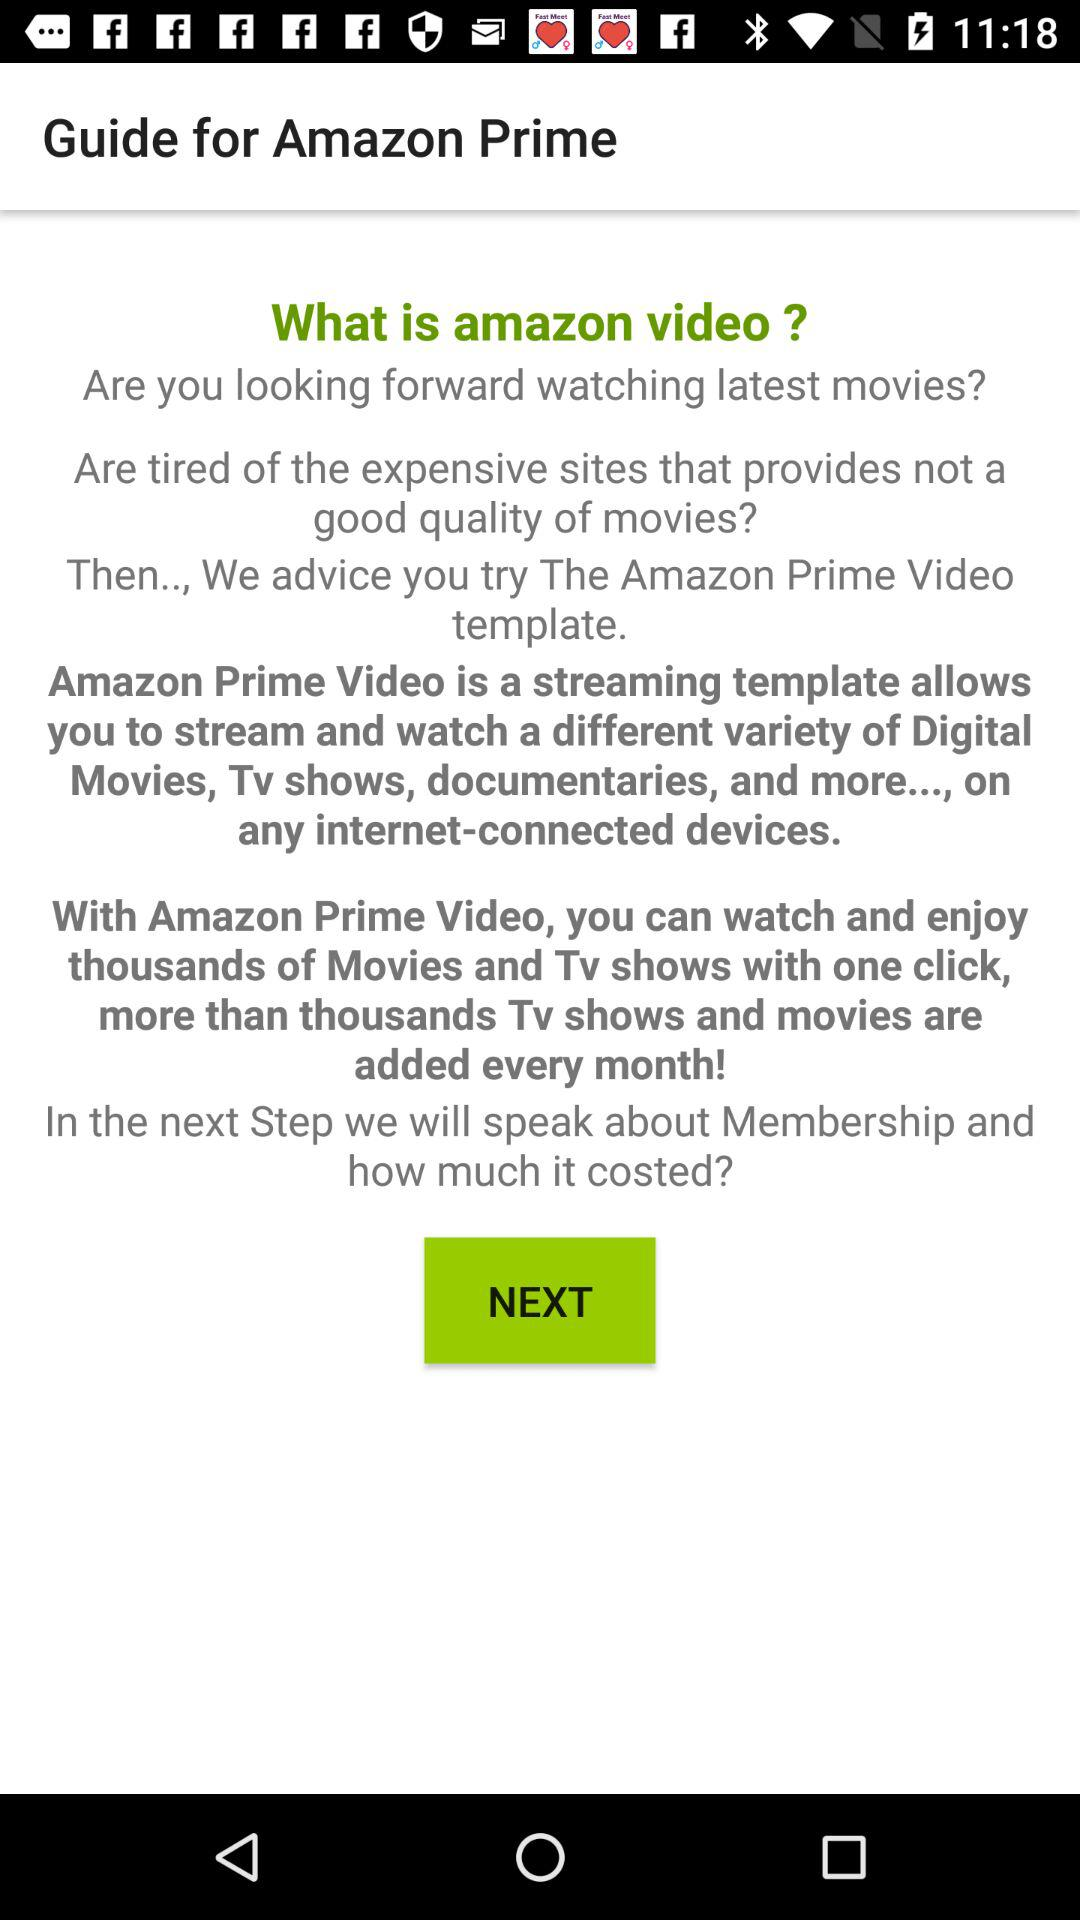What is the name of the application? The name of the application is "Guide for Amazon Prime". 